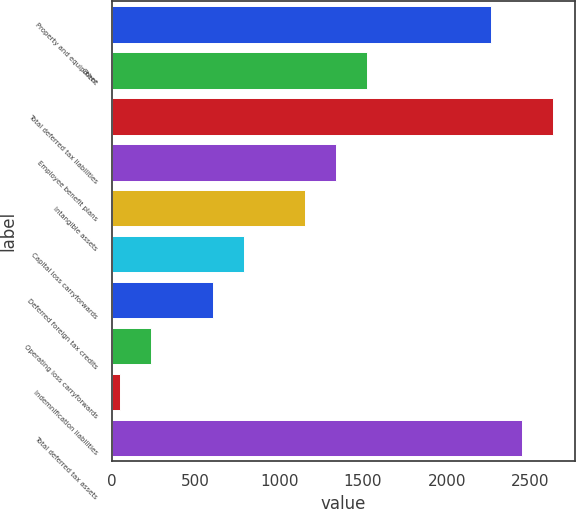Convert chart. <chart><loc_0><loc_0><loc_500><loc_500><bar_chart><fcel>Property and equipment<fcel>Other<fcel>Total deferred tax liabilities<fcel>Employee benefit plans<fcel>Intangible assets<fcel>Capital loss carryforwards<fcel>Deferred foreign tax credits<fcel>Operating loss carryforwards<fcel>Indemnification liabilities<fcel>Total deferred tax assets<nl><fcel>2264.8<fcel>1526.4<fcel>2634<fcel>1341.8<fcel>1157.2<fcel>788<fcel>603.4<fcel>234.2<fcel>49.6<fcel>2449.4<nl></chart> 